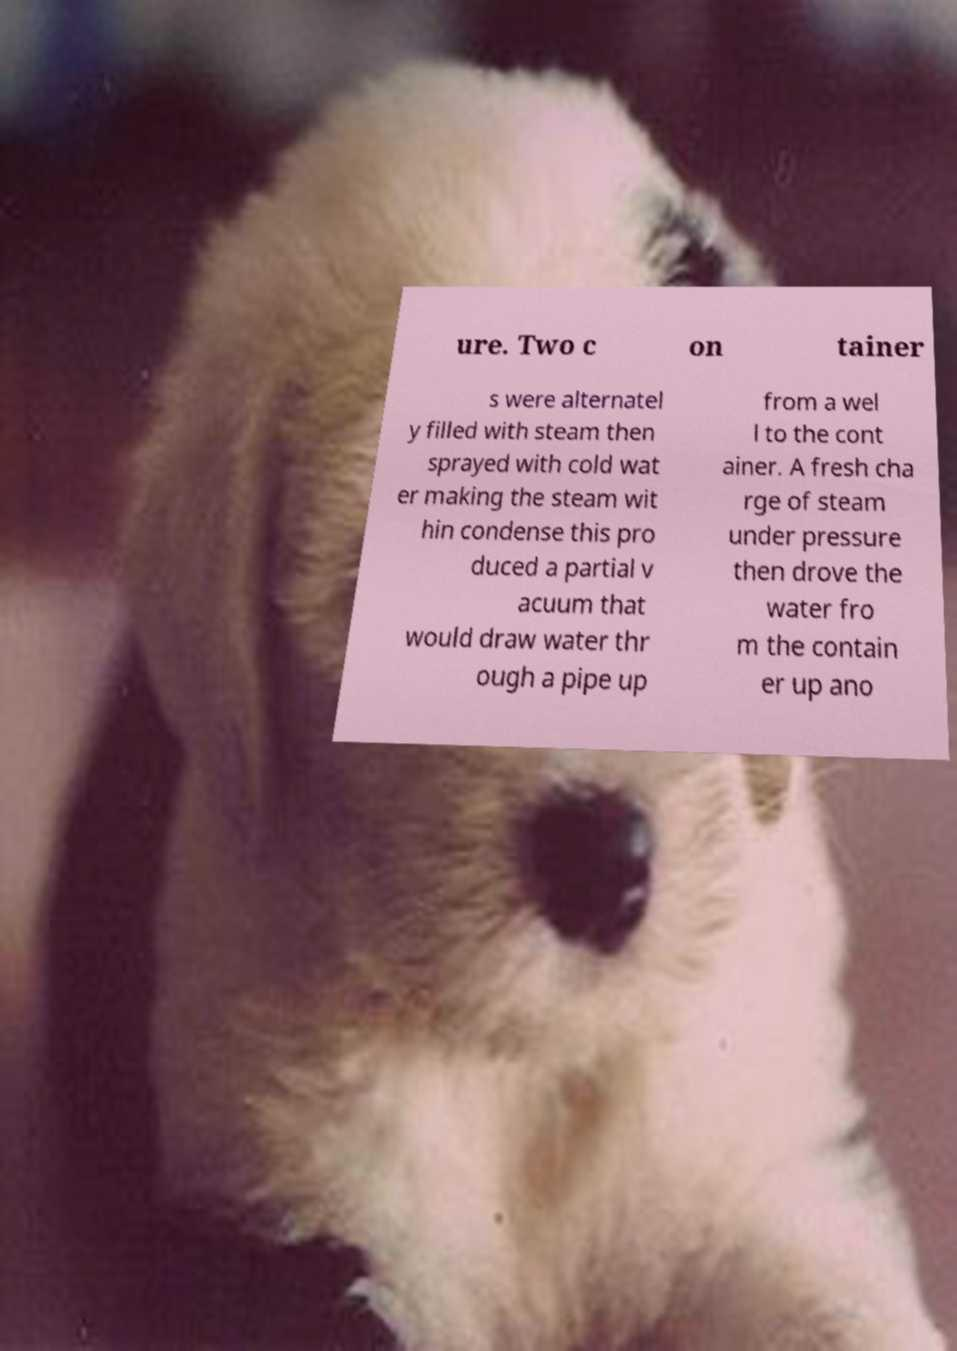Can you read and provide the text displayed in the image?This photo seems to have some interesting text. Can you extract and type it out for me? ure. Two c on tainer s were alternatel y filled with steam then sprayed with cold wat er making the steam wit hin condense this pro duced a partial v acuum that would draw water thr ough a pipe up from a wel l to the cont ainer. A fresh cha rge of steam under pressure then drove the water fro m the contain er up ano 